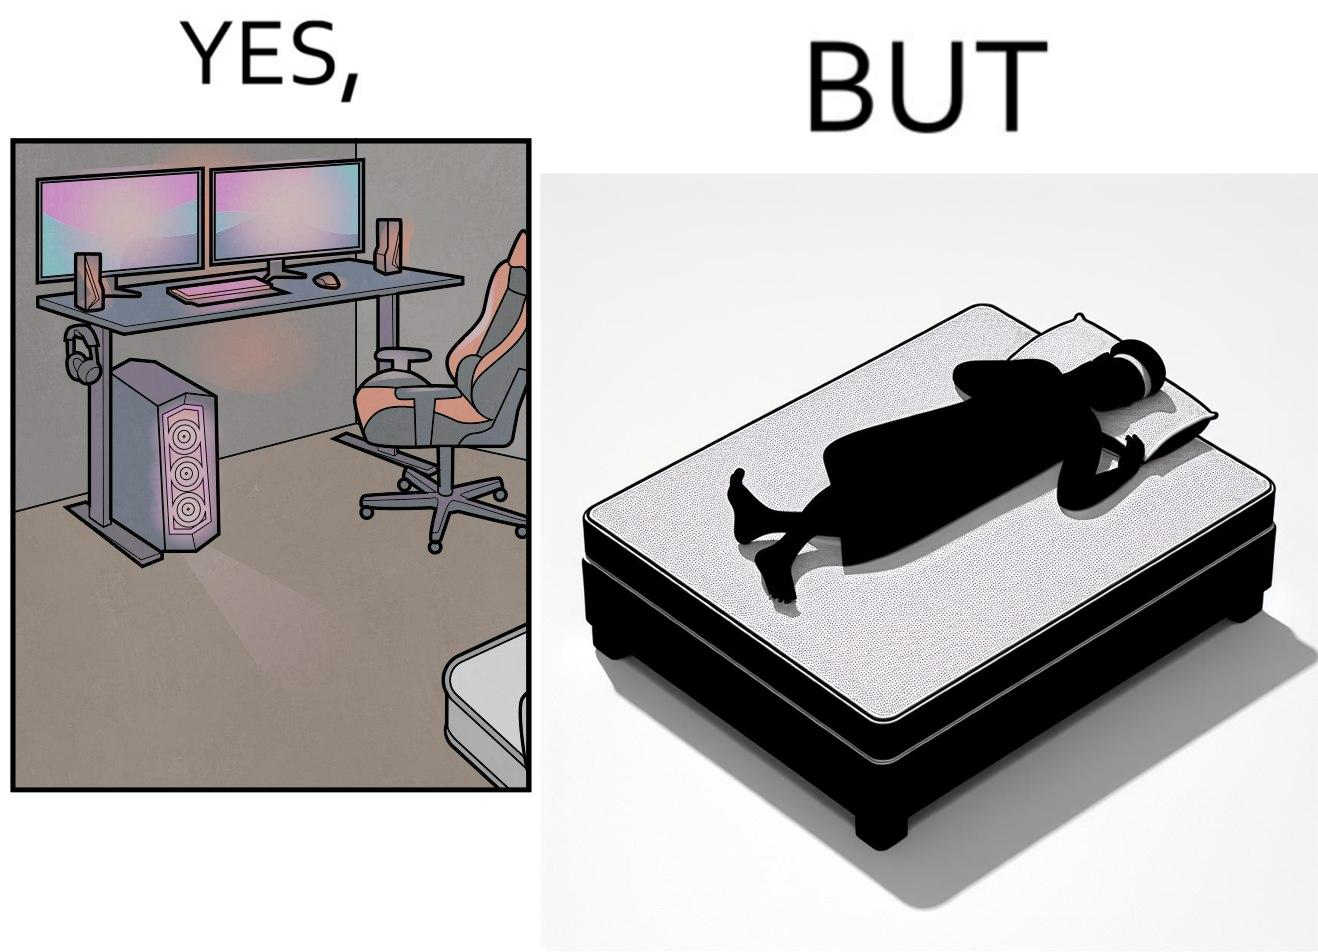Describe the content of this image. The image is funny because the person has a lot of furniture for his computer but none for himself. 